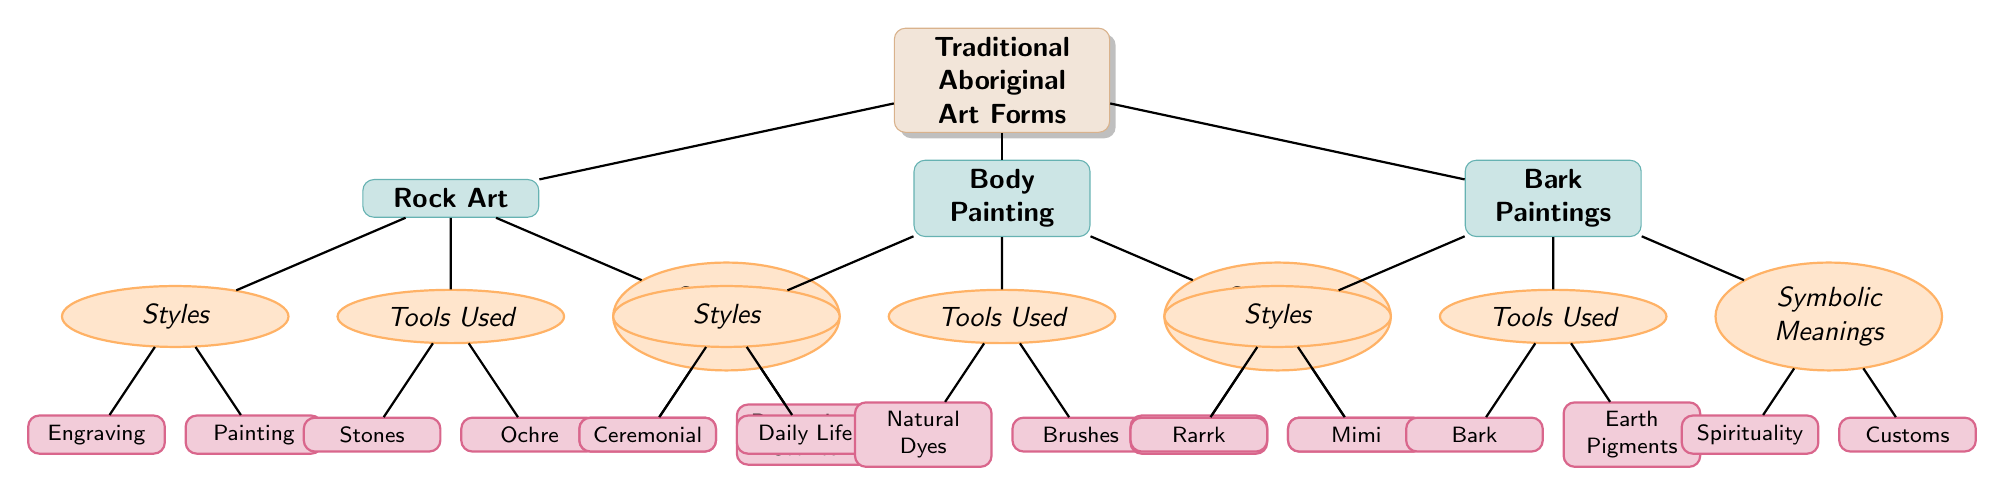What are the three main categories of traditional Aboriginal art forms? The diagram’s main nodes under "Traditional Aboriginal Art Forms" are "Rock Art," "Body Painting," and "Bark Paintings," which represent the primary categories.
Answer: Rock Art, Body Painting, Bark Paintings How many distinct styles are listed under Body Painting? Under the "Body Painting" category, there are two styles indicated: "Ceremonial" and "Daily Life." Thus, the total count is two.
Answer: 2 What tool is used in Rock Art for painting? Referring to the "Tools Used" section beneath "Rock Art," "Ochre" is listed as one of the tools specifically associated with painting.
Answer: Ochre Which symbolic meaning is associated with Bark Paintings? The "Symbolic Meanings" subsection of "Bark Paintings" includes "Spirituality" and "Customs," signifying that either could be associated. Here, the question specifically mentions "Bark Paintings."
Answer: Spirituality How many tools are mentioned under the Bark Paintings category? In the "Bark Paintings" category under "Tools Used," there are two tools listed: "Bark" and "Earth Pigments," making the total count of tools two.
Answer: 2 What style of Rock Art involves Engraving? The "Rock Art" category specifies "Engraving" as one of the two styles listed under "Styles," directly indicating it as a type of Rock Art.
Answer: Engraving What are the two contexts identified for the symbolic meaning of body painting? Under the "Symbolic Meanings" section for "Body Painting," both "Identity" and "Protection" are indicated as meanings, representing the contexts associated with body painting.
Answer: Identity, Protection Which traditional art form uses natural dyes in its tools? The "Body Painting" category specifies "Natural Dyes" under "Tools Used," which indicates that this art form utilizes natural dyes for its creations.
Answer: Body Painting What does the primary node 'Traditional Aboriginal Art Forms' represent? The primary node “Traditional Aboriginal Art Forms” encompasses the various artistic expressions of Aboriginal cultures, summarizing the entire diagram's focus.
Answer: Aboriginal art traditions 